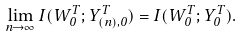Convert formula to latex. <formula><loc_0><loc_0><loc_500><loc_500>\lim _ { n \to \infty } I ( W _ { 0 } ^ { T } ; Y _ { ( n ) , 0 } ^ { T } ) = I ( W _ { 0 } ^ { T } ; Y _ { 0 } ^ { T } ) .</formula> 